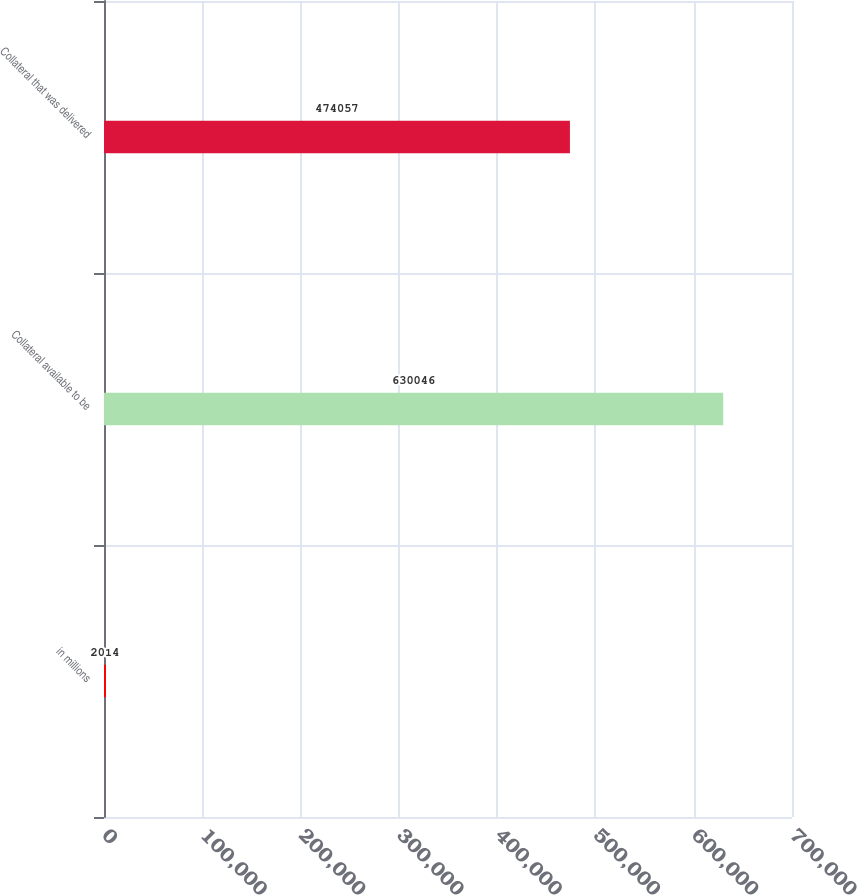Convert chart to OTSL. <chart><loc_0><loc_0><loc_500><loc_500><bar_chart><fcel>in millions<fcel>Collateral available to be<fcel>Collateral that was delivered<nl><fcel>2014<fcel>630046<fcel>474057<nl></chart> 